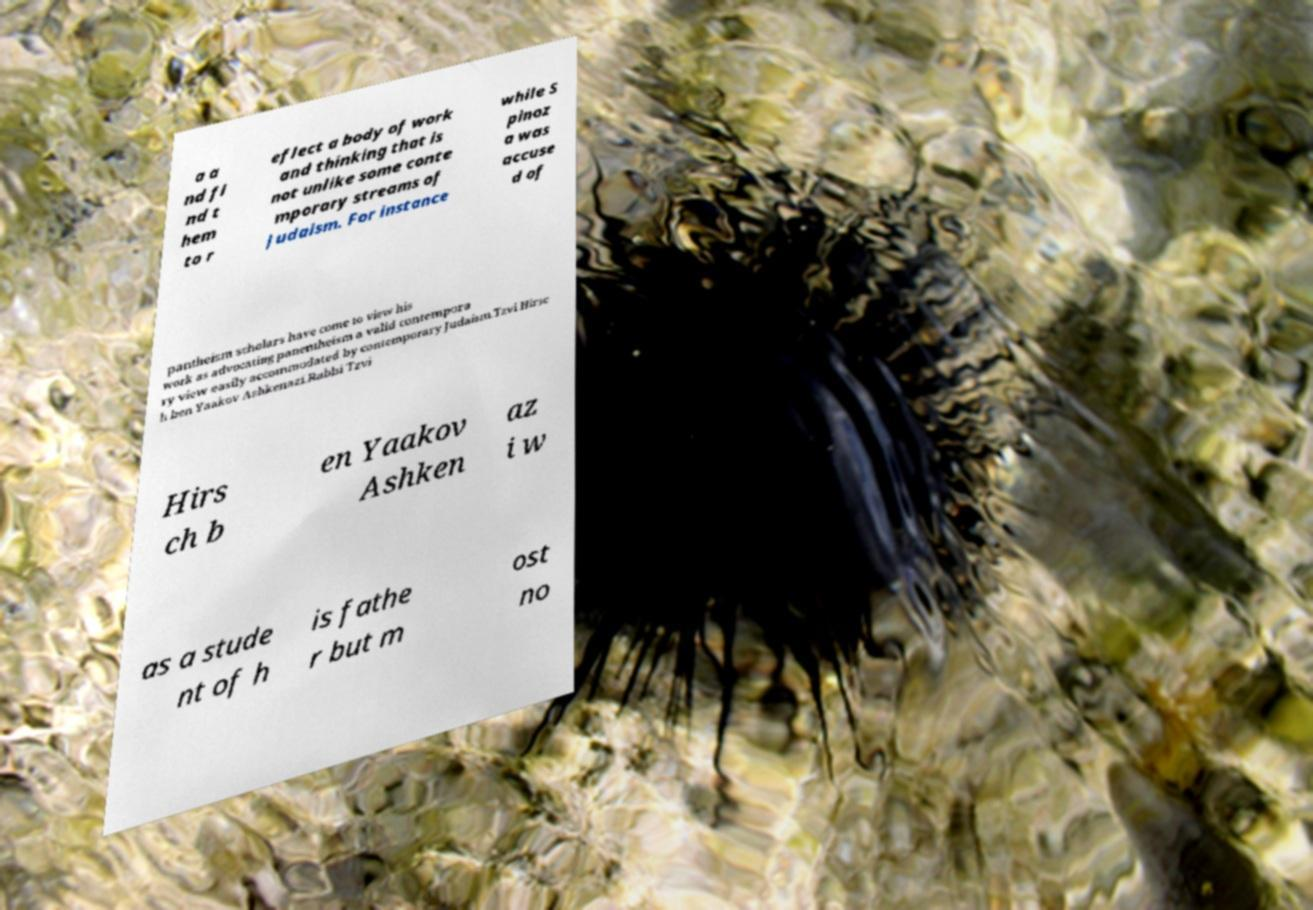For documentation purposes, I need the text within this image transcribed. Could you provide that? a a nd fi nd t hem to r eflect a body of work and thinking that is not unlike some conte mporary streams of Judaism. For instance while S pinoz a was accuse d of pantheism scholars have come to view his work as advocating panentheism a valid contempora ry view easily accommodated by contemporary Judaism.Tzvi Hirsc h ben Yaakov Ashkenazi.Rabbi Tzvi Hirs ch b en Yaakov Ashken az i w as a stude nt of h is fathe r but m ost no 